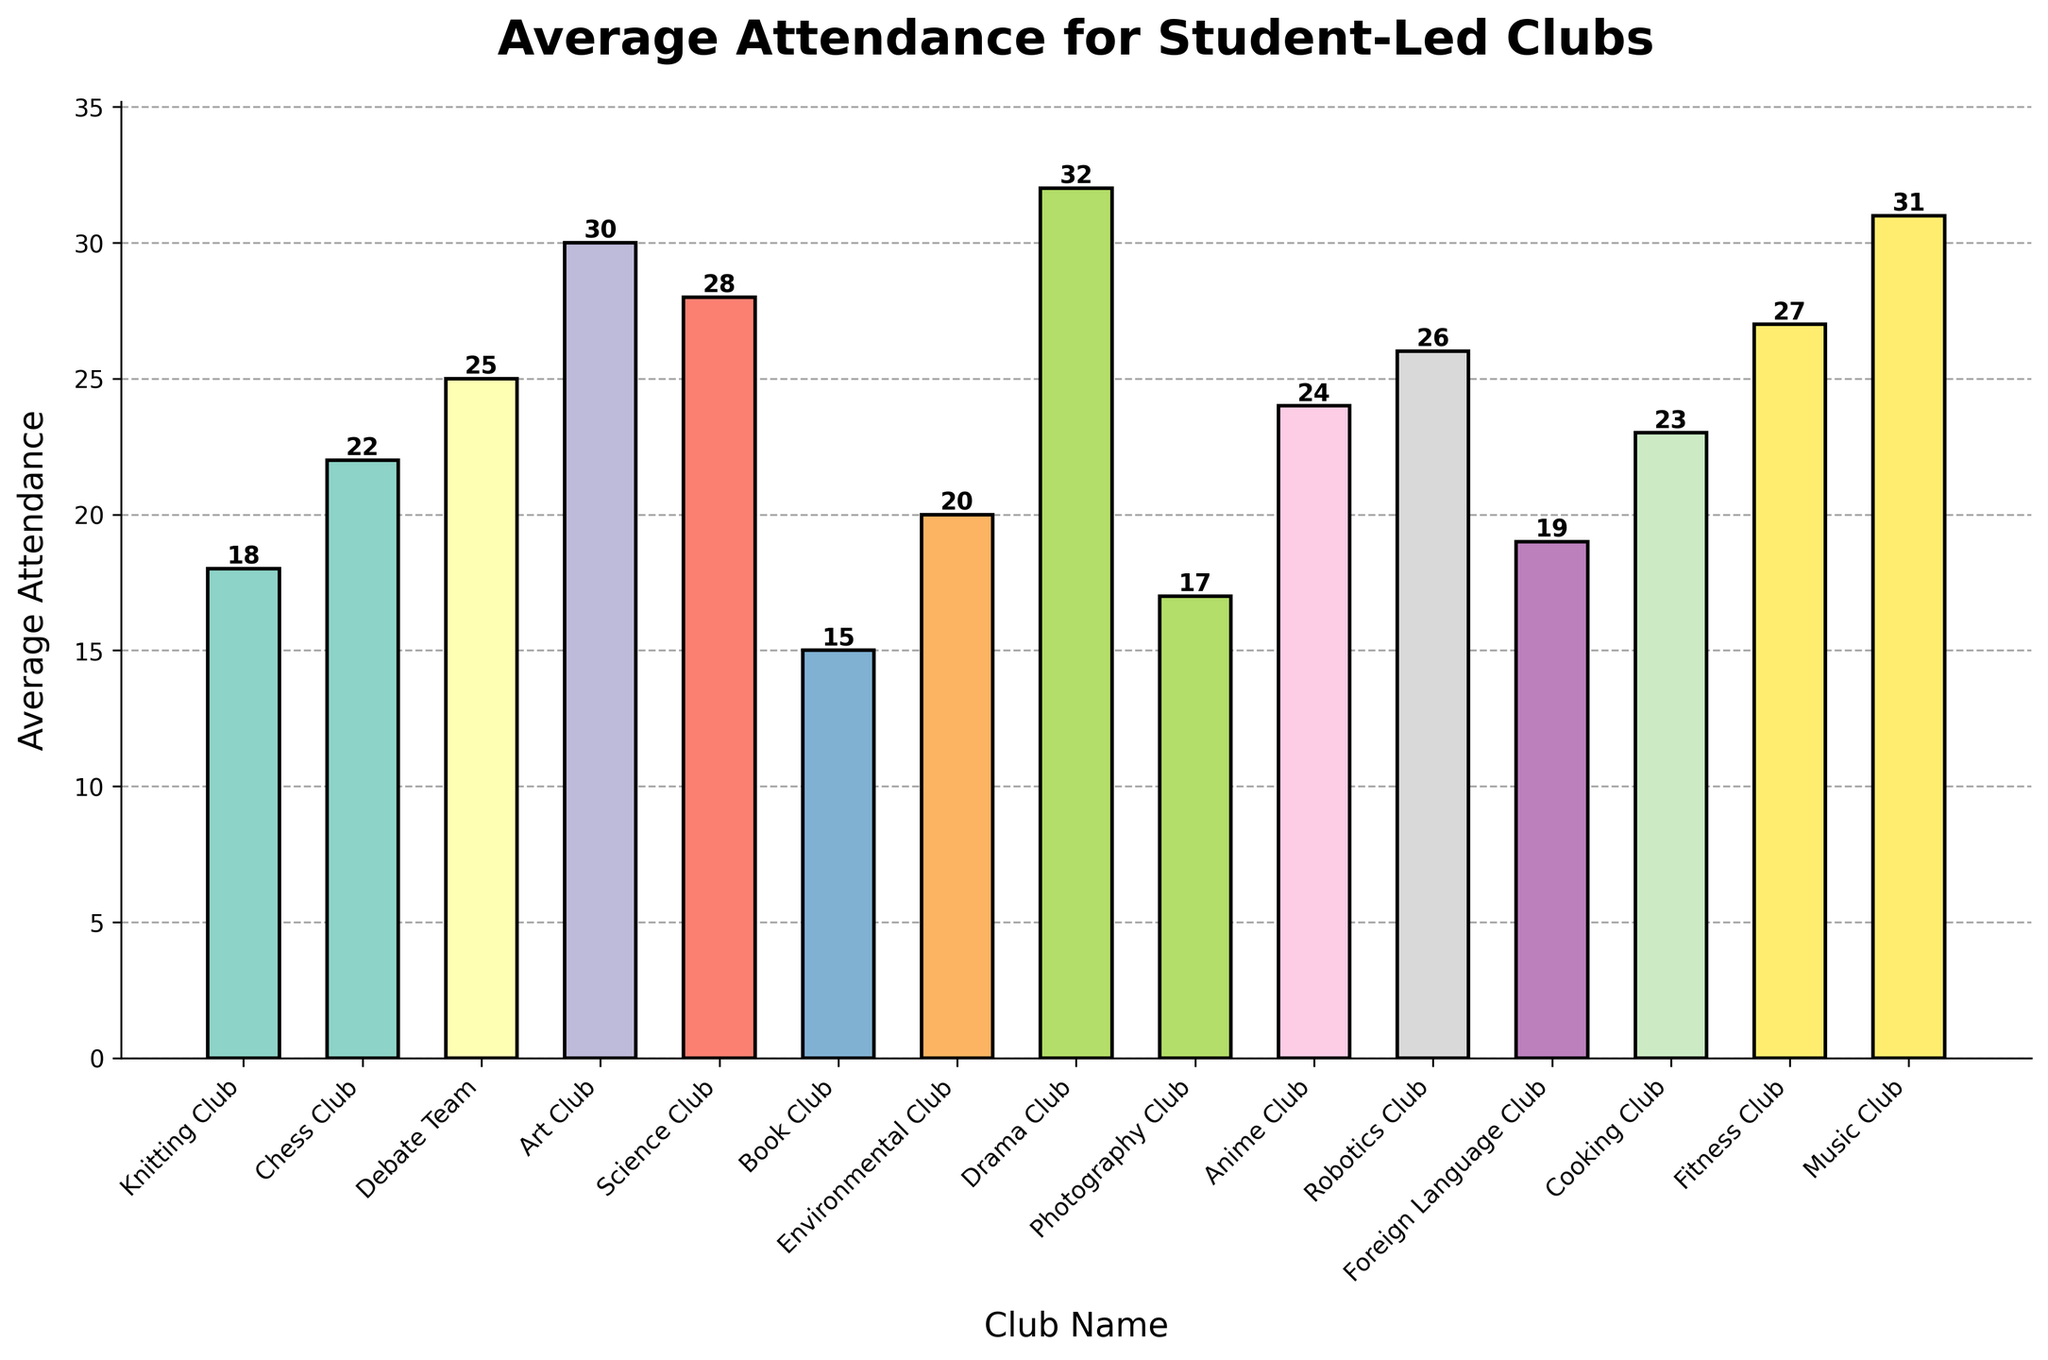What is the club with the highest average attendance? Look at the heights of the bars and identify the one that reaches the highest point. The Drama Club has the tallest bar.
Answer: Drama Club Which clubs have an average attendance higher than the Knitting Club? Compare the height of the Knitting Club bar with the other bars. The clubs with higher bars than the Knitting Club are Chess Club, Debate Team, Art Club, Science Club, Drama Club, Anime Club, Robotics Club, Cooking Club, Fitness Club, and Music Club.
Answer: Chess Club, Debate Team, Art Club, Science Club, Drama Club, Anime Club, Robotics Club, Cooking Club, Fitness Club, Music Club What is the average attendance of the clubs with the top three highest attendance? Identify the three clubs with the tallest bars, which are Drama Club (32), Music Club (31), and Art Club (30). Sum these values and divide by 3 to get the average: (32 + 31 + 30)/3 = 93/3 = 31.
Answer: 31 Is the Fitness Club's average attendance higher or lower than the Cooking Club's? Compare the height of the bars for Fitness Club and Cooking Club. The Fitness Club attendance is taller (27) than the Cooking Club's (23).
Answer: Higher How many clubs have an average attendance of 20 or more? Count all the bars that reach at least the height of 20 or more. Clubs meeting this criteria include Chess Club, Debate Team, Art Club, Science Club, Drama Club, Anime Club, Robotics Club, Cooking Club, Fitness Club, and Music Club.
Answer: 10 Which club has the closest average attendance to 20? Identify the bars close to the height of 20. The club that has an attendance closest to 20 is the Environmental Club, which exactly matches 20.
Answer: Environmental Club What is the difference in average attendance between the Chess Club and the Book Club? Find the heights of both bars: Chess Club (22) and Book Club (15). Subtract the smaller from the larger: 22 - 15 = 7.
Answer: 7 Which clubs have an average attendance that is less than 18? Compare the height of the bars to see which are below 18. The bars for Book Club and Photography Club are below 18.
Answer: Book Club, Photography Club What is the total average attendance of all the clubs? Sum the heights of all the bars: 18 + 22 + 25 + 30 + 28 + 15 + 20 + 32 + 17 + 24 + 26 + 19 + 23 + 27 + 31 = 357.
Answer: 357 How much higher is the Drama Club’s average attendance compared to the Knitting Club? Subtract the height of the Knitting Club bar from the Drama Club bar: 32 - 18 = 14.
Answer: 14 